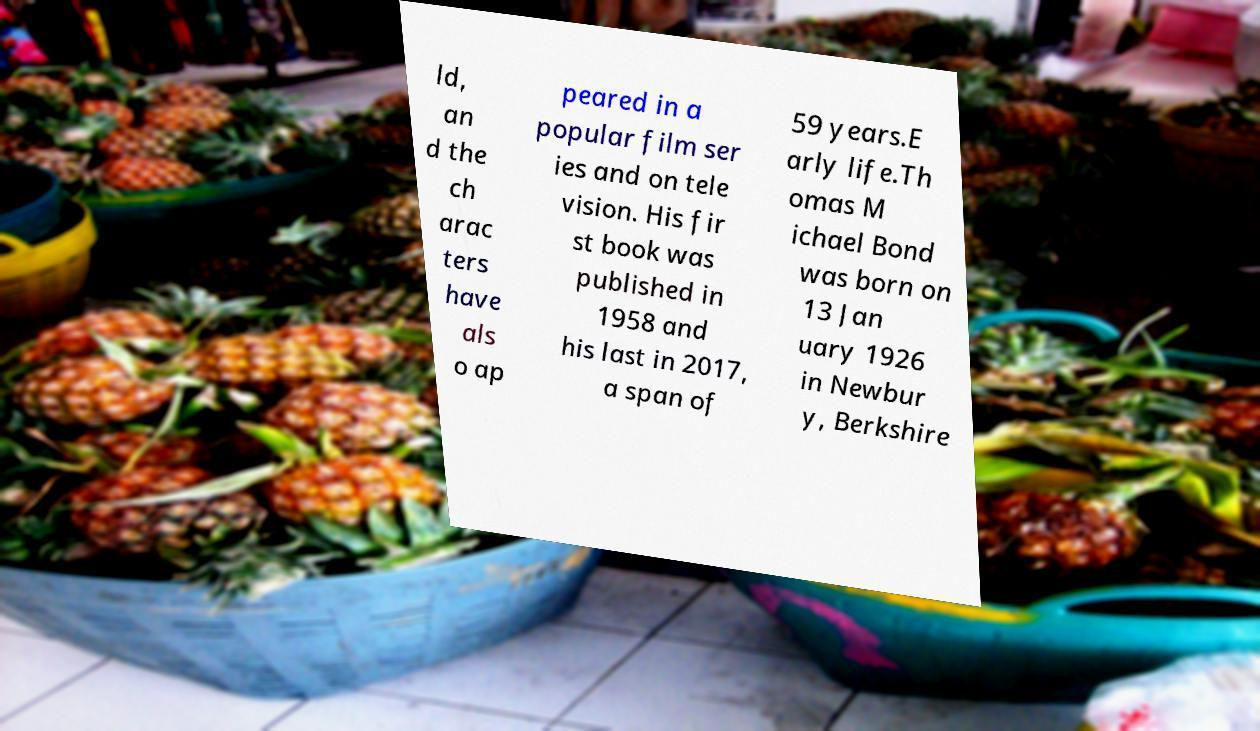Can you accurately transcribe the text from the provided image for me? ld, an d the ch arac ters have als o ap peared in a popular film ser ies and on tele vision. His fir st book was published in 1958 and his last in 2017, a span of 59 years.E arly life.Th omas M ichael Bond was born on 13 Jan uary 1926 in Newbur y, Berkshire 